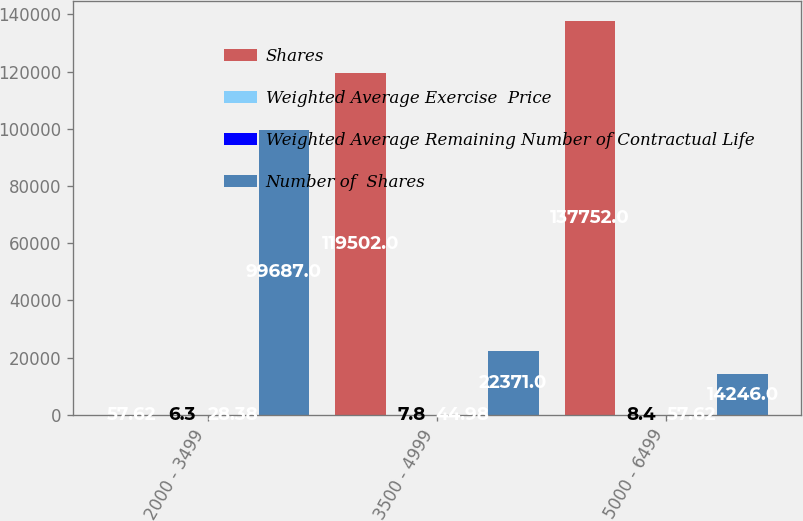Convert chart. <chart><loc_0><loc_0><loc_500><loc_500><stacked_bar_chart><ecel><fcel>2000 - 3499<fcel>3500 - 4999<fcel>5000 - 6499<nl><fcel>Shares<fcel>57.62<fcel>119502<fcel>137752<nl><fcel>Weighted Average Exercise  Price<fcel>6.3<fcel>7.8<fcel>8.4<nl><fcel>Weighted Average Remaining Number of Contractual Life<fcel>28.38<fcel>44.98<fcel>57.62<nl><fcel>Number of  Shares<fcel>99687<fcel>22371<fcel>14246<nl></chart> 